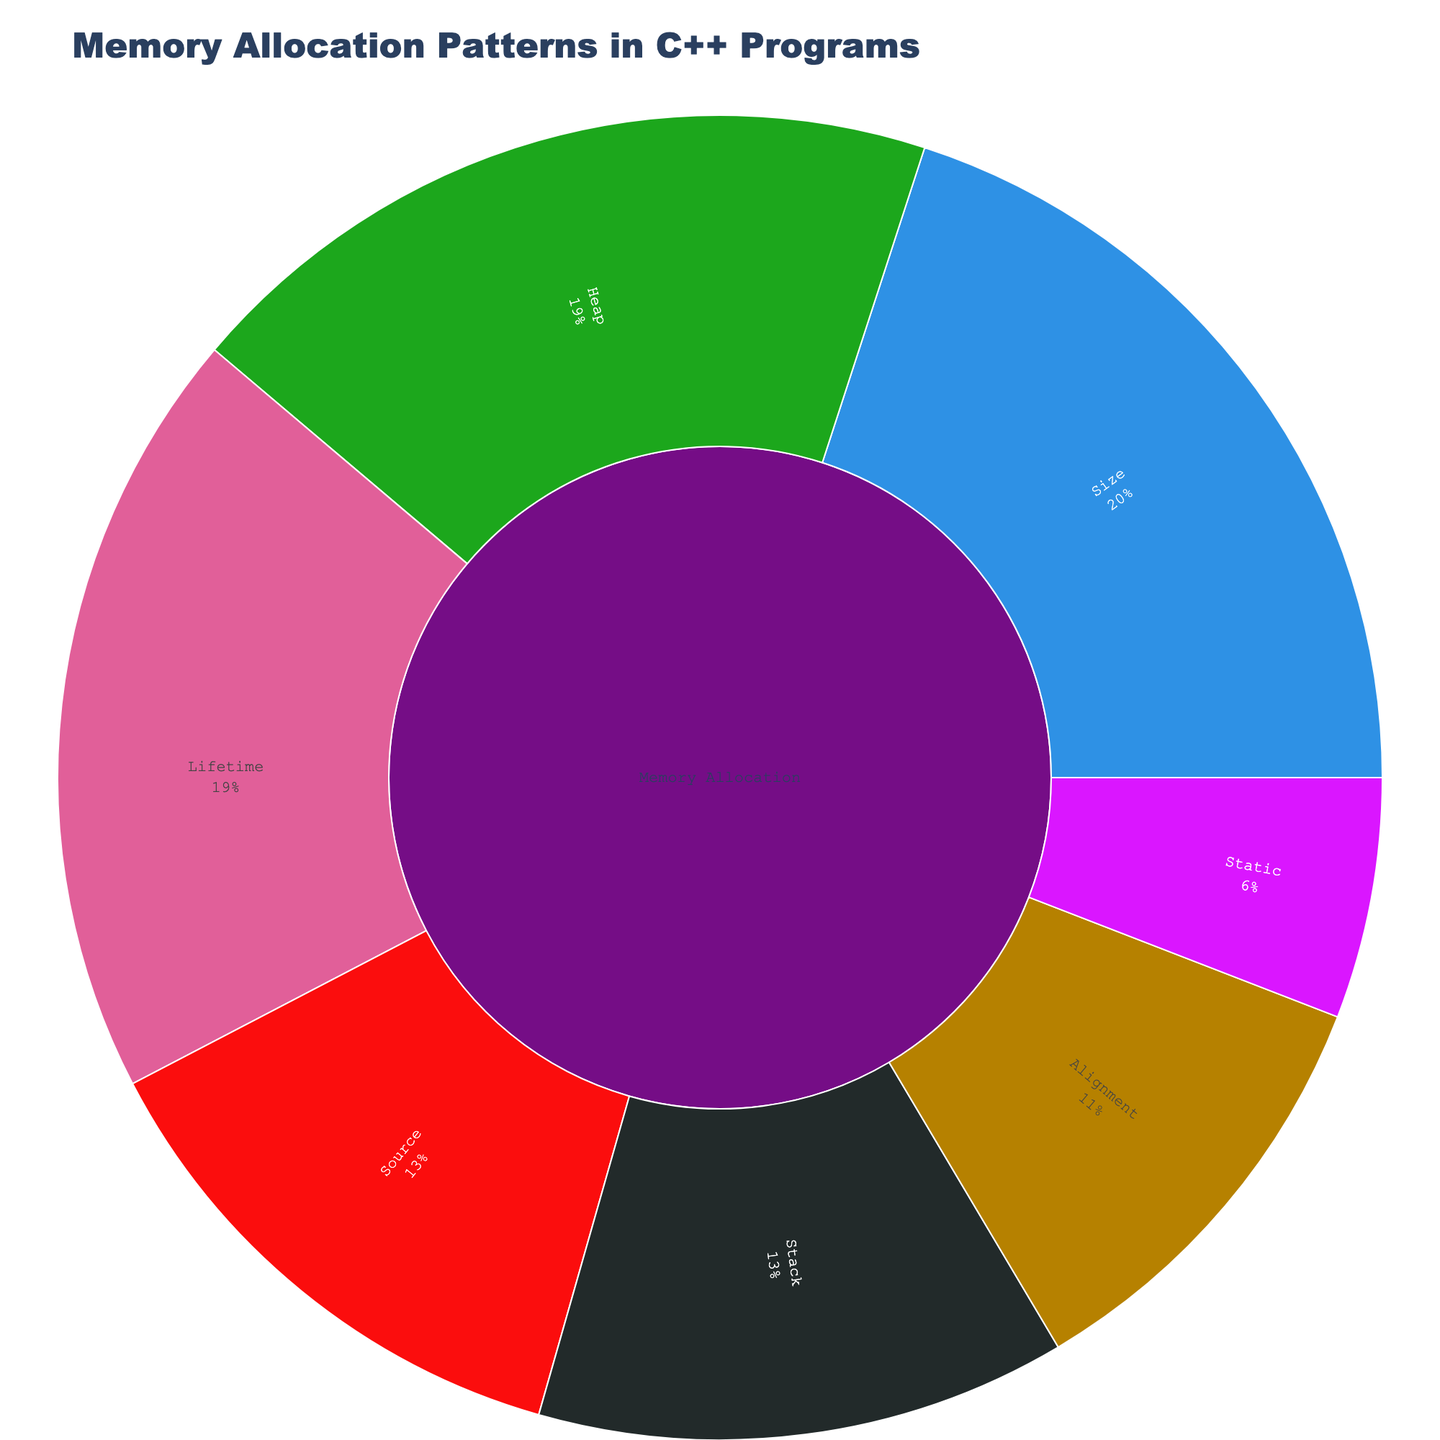Which category has the highest allocation value? By looking at the sunburst plot, you will notice different color-coded categories. Check which color-coded category has the largest segment relative to others.
Answer: Stack What's the percentage value of 'STL Containers' within the 'Heap' category? Hover over the 'STL Containers' segment of the 'Heap' category in the sunburst plot to see the percentage of total memory allocations it forms within its parent category 'Heap'.
Answer: 43.8% How does the allocation for 'Function Parameters' compare to 'Return Addresses' within the Stack category? Compare the two segments within the 'Stack' category labeled 'Function Parameters' and 'Return Addresses'. 'Function Parameters' has a larger area than 'Return Addresses', indicating it has a higher allocation value.
Answer: Function Parameters are larger Which subcategory has the smallest allocation value in the 'Static' category? Look at the subcategory segments within the 'Static' category. The 'Const Variables' segment is the smallest one.
Answer: Const Variables What is the total allocation value for medium-sized allocations? The sunburst plot allocates values to different size categories. Locate 'Medium (64-1024 bytes)' under the 'Size' category. This value is displayed directly within that segment.
Answer: 30 How does 'Boost Libraries' allocation compare to 'Custom Allocators' within the 'Source' category? Both 'Boost Libraries' and 'Custom Allocators' are subcategories under 'Source.' Compare their segment sizes: 'Boost Libraries' is larger than 'Custom Allocators'.
Answer: Boost Libraries have a higher allocation What percentage of memory allocation is done using the 'malloc' function within the 'Heap' category? Hover over the segment labeled 'malloc Function' within the 'Heap' category. The percentage value relative to the parent category 'Heap' is displayed in the hover tooltip.
Answer: 25% Which allocation type has the most significant percentage of 'Short-lived' allocations under 'Lifetime'? Find the 'Short-lived' segment under the 'Lifetime' category and check which type it branches from. 'Short-lived' forms from different allocations types, so look for the largest proportion.
Answer: Stack Are 'STL Containers' the largest contributor to memory allocation in the 'Heap' category? Examine the plot segments of the 'Heap' category. 'STL Containers' has the largest segment within 'Heap', suggesting it is the largest contributor.
Answer: Yes 